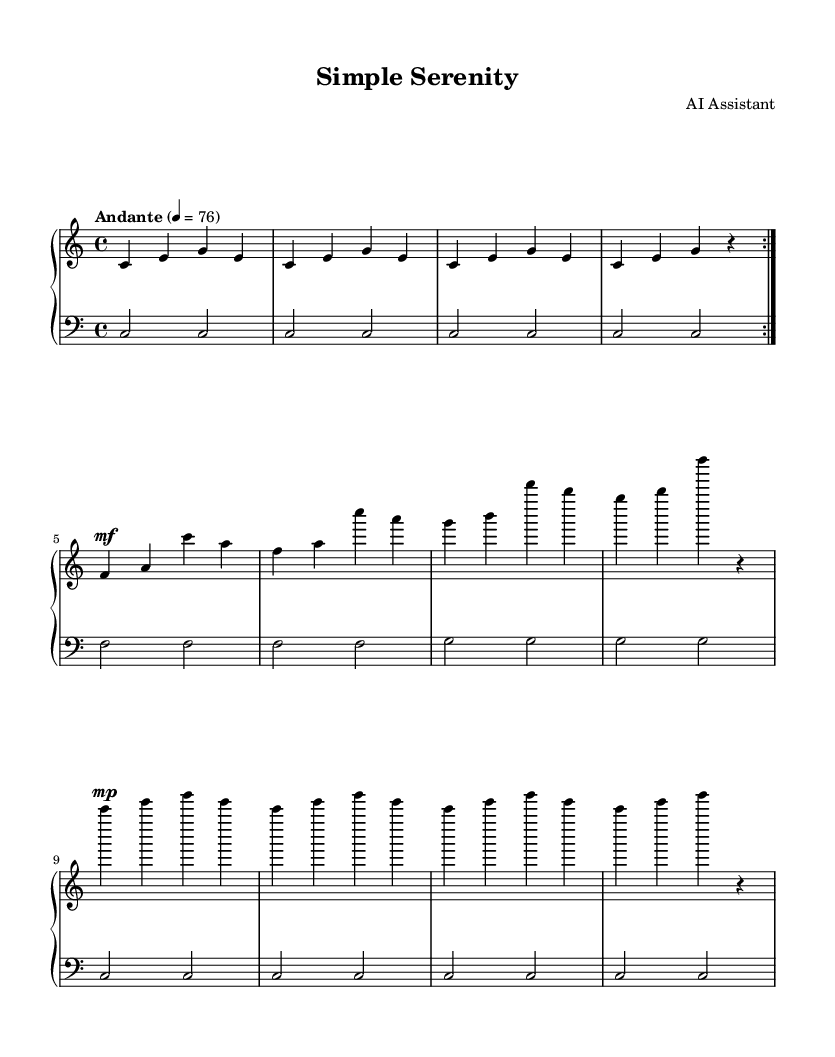What is the key signature of this music? The key signature is indicated by the lack of sharps or flats at the beginning of the staff, meaning it is C major.
Answer: C major What is the time signature of this music? The time signature is shown at the beginning, represented by the fraction 4/4, indicating four beats per measure.
Answer: 4/4 What is the tempo marking of this piece? The tempo marking is found at the beginning of the score where it states "Andante" with a metronome marking of 76, suggesting a moderately slow pace.
Answer: Andante 4 = 76 How many sections does the piece have? The piece contains three sections: Section A, Section B, and a repeat of Section A, as indicated by the markings on the score.
Answer: Three What dynamics are indicated in this score? The dynamics include a "mf" marking, which is a moderate loudness, as well as "mp," indicating a moderately soft volume.
Answer: mf, mp How many measures are in Section A? Section A has a total of 8 measures, as inferred by counting the 4 measures in the first and repeated sections.
Answer: 8 What instruments are indicated in this sheet music? The score indicates the use of a piano by showing a PianoStaff, which incorporates both treble and bass staves for right and left hands.
Answer: Piano 